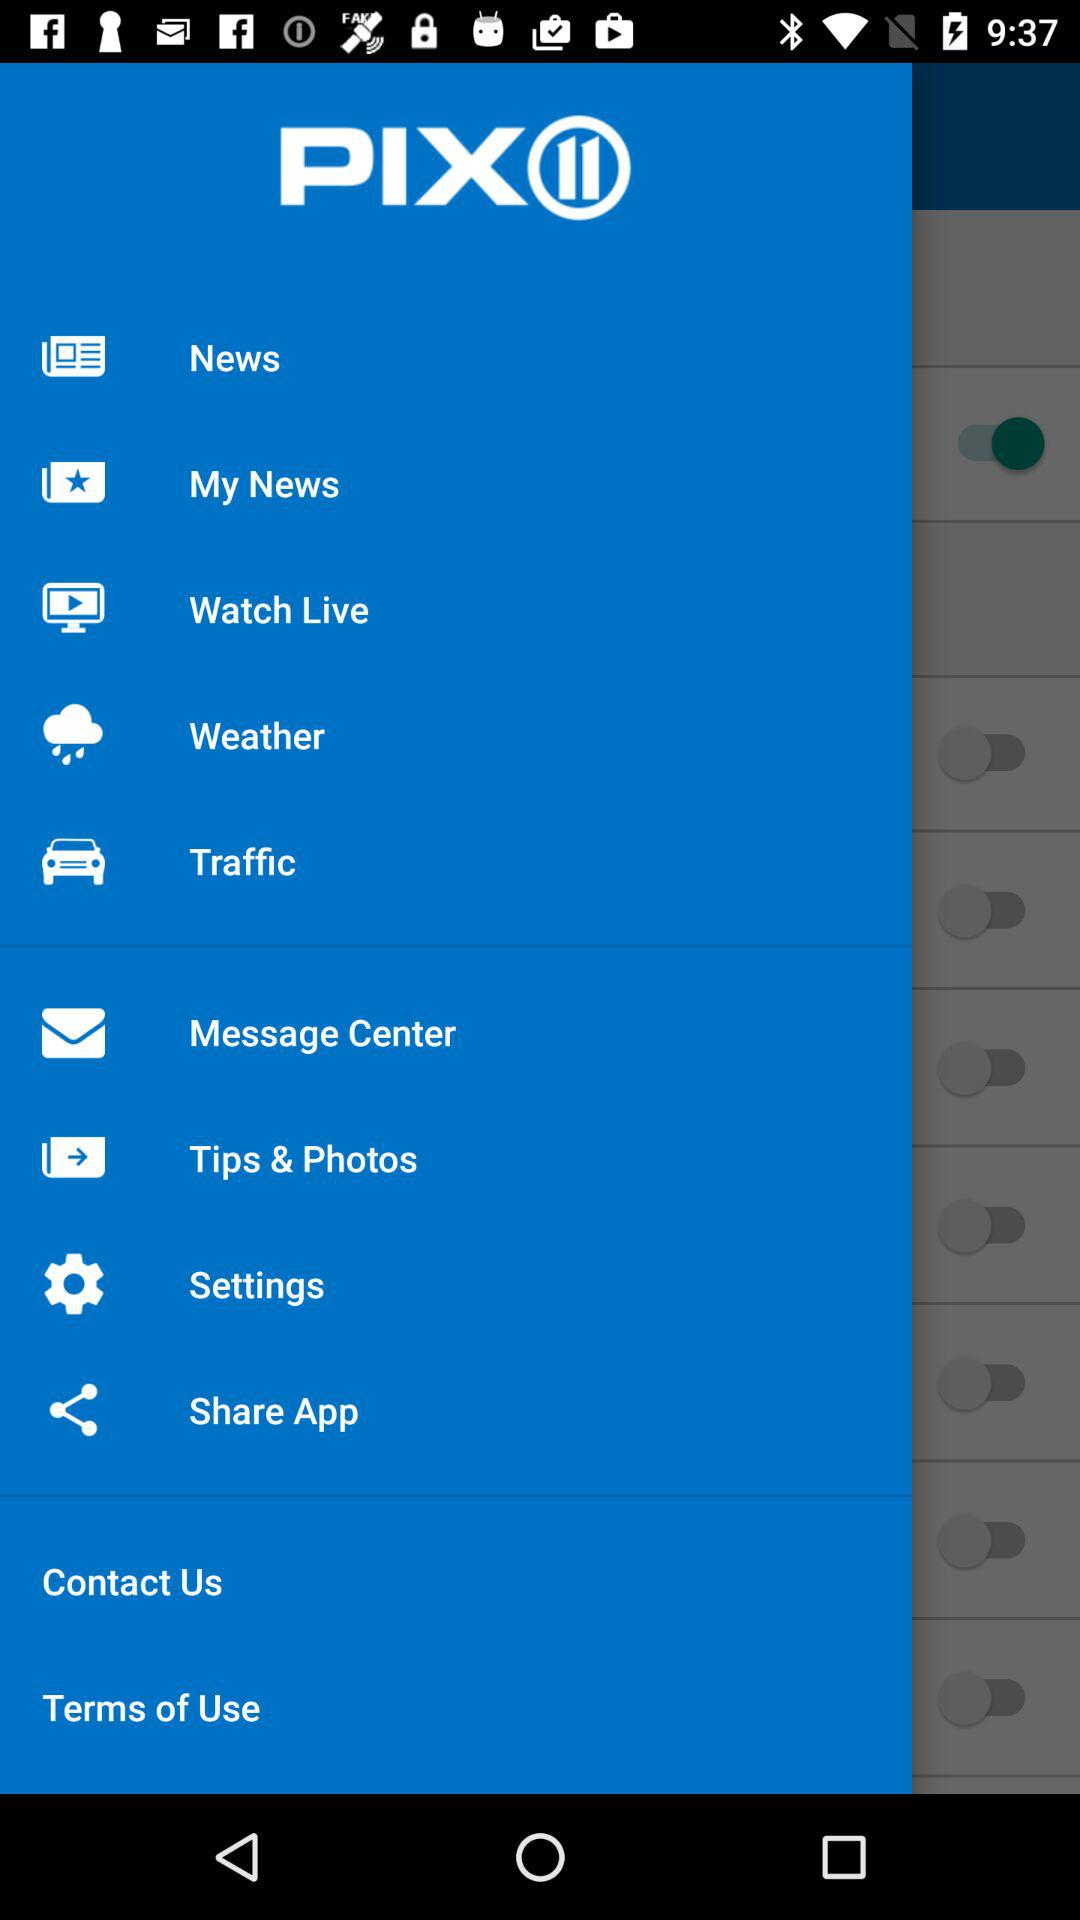What is the name of the application? The application name is "PIX(II)". 